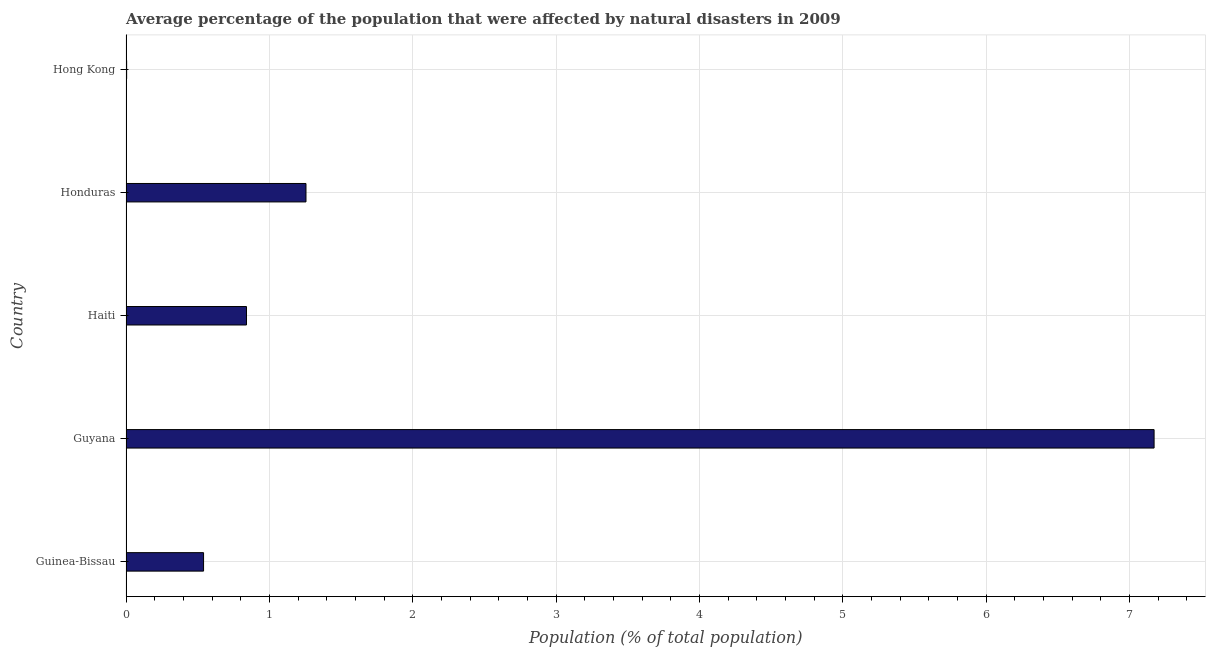Does the graph contain any zero values?
Keep it short and to the point. No. Does the graph contain grids?
Provide a short and direct response. Yes. What is the title of the graph?
Offer a very short reply. Average percentage of the population that were affected by natural disasters in 2009. What is the label or title of the X-axis?
Offer a terse response. Population (% of total population). What is the percentage of population affected by droughts in Hong Kong?
Keep it short and to the point. 0. Across all countries, what is the maximum percentage of population affected by droughts?
Your answer should be very brief. 7.17. Across all countries, what is the minimum percentage of population affected by droughts?
Provide a succinct answer. 0. In which country was the percentage of population affected by droughts maximum?
Ensure brevity in your answer.  Guyana. In which country was the percentage of population affected by droughts minimum?
Your response must be concise. Hong Kong. What is the sum of the percentage of population affected by droughts?
Your answer should be compact. 9.81. What is the difference between the percentage of population affected by droughts in Guinea-Bissau and Honduras?
Provide a short and direct response. -0.71. What is the average percentage of population affected by droughts per country?
Your response must be concise. 1.96. What is the median percentage of population affected by droughts?
Offer a very short reply. 0.84. In how many countries, is the percentage of population affected by droughts greater than 4.4 %?
Your response must be concise. 1. What is the ratio of the percentage of population affected by droughts in Guinea-Bissau to that in Haiti?
Offer a very short reply. 0.64. Is the percentage of population affected by droughts in Honduras less than that in Hong Kong?
Give a very brief answer. No. What is the difference between the highest and the second highest percentage of population affected by droughts?
Offer a very short reply. 5.92. Is the sum of the percentage of population affected by droughts in Guinea-Bissau and Haiti greater than the maximum percentage of population affected by droughts across all countries?
Provide a short and direct response. No. What is the difference between the highest and the lowest percentage of population affected by droughts?
Keep it short and to the point. 7.17. In how many countries, is the percentage of population affected by droughts greater than the average percentage of population affected by droughts taken over all countries?
Provide a short and direct response. 1. Are all the bars in the graph horizontal?
Offer a terse response. Yes. What is the Population (% of total population) of Guinea-Bissau?
Your response must be concise. 0.54. What is the Population (% of total population) in Guyana?
Make the answer very short. 7.17. What is the Population (% of total population) in Haiti?
Your answer should be compact. 0.84. What is the Population (% of total population) of Honduras?
Keep it short and to the point. 1.26. What is the Population (% of total population) in Hong Kong?
Your answer should be very brief. 0. What is the difference between the Population (% of total population) in Guinea-Bissau and Guyana?
Provide a succinct answer. -6.63. What is the difference between the Population (% of total population) in Guinea-Bissau and Haiti?
Your answer should be compact. -0.3. What is the difference between the Population (% of total population) in Guinea-Bissau and Honduras?
Provide a succinct answer. -0.71. What is the difference between the Population (% of total population) in Guinea-Bissau and Hong Kong?
Your response must be concise. 0.54. What is the difference between the Population (% of total population) in Guyana and Haiti?
Offer a very short reply. 6.33. What is the difference between the Population (% of total population) in Guyana and Honduras?
Your answer should be very brief. 5.92. What is the difference between the Population (% of total population) in Guyana and Hong Kong?
Provide a short and direct response. 7.17. What is the difference between the Population (% of total population) in Haiti and Honduras?
Provide a short and direct response. -0.41. What is the difference between the Population (% of total population) in Haiti and Hong Kong?
Give a very brief answer. 0.84. What is the difference between the Population (% of total population) in Honduras and Hong Kong?
Offer a very short reply. 1.25. What is the ratio of the Population (% of total population) in Guinea-Bissau to that in Guyana?
Give a very brief answer. 0.07. What is the ratio of the Population (% of total population) in Guinea-Bissau to that in Haiti?
Offer a terse response. 0.64. What is the ratio of the Population (% of total population) in Guinea-Bissau to that in Honduras?
Provide a short and direct response. 0.43. What is the ratio of the Population (% of total population) in Guinea-Bissau to that in Hong Kong?
Your answer should be compact. 124.22. What is the ratio of the Population (% of total population) in Guyana to that in Haiti?
Your answer should be very brief. 8.53. What is the ratio of the Population (% of total population) in Guyana to that in Honduras?
Your answer should be very brief. 5.71. What is the ratio of the Population (% of total population) in Guyana to that in Hong Kong?
Ensure brevity in your answer.  1646.76. What is the ratio of the Population (% of total population) in Haiti to that in Honduras?
Provide a succinct answer. 0.67. What is the ratio of the Population (% of total population) in Haiti to that in Hong Kong?
Keep it short and to the point. 192.98. What is the ratio of the Population (% of total population) in Honduras to that in Hong Kong?
Provide a succinct answer. 288.28. 